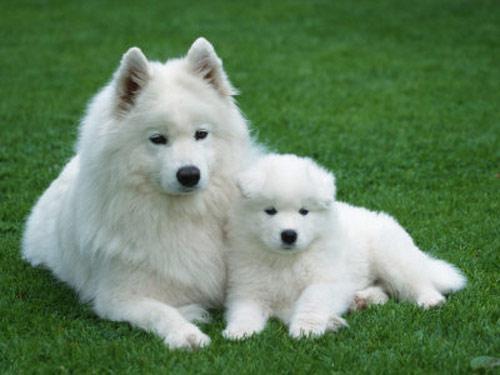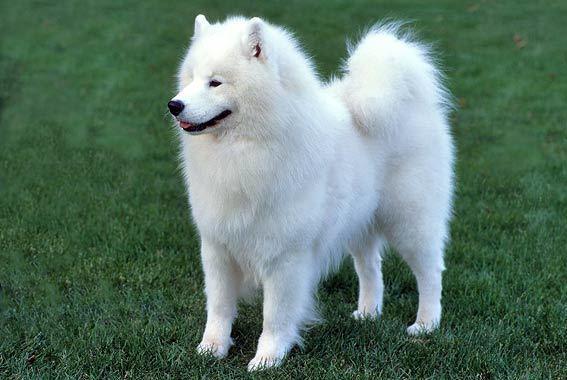The first image is the image on the left, the second image is the image on the right. Evaluate the accuracy of this statement regarding the images: "Combined, the images contain exactly four animals.". Is it true? Answer yes or no. No. The first image is the image on the left, the second image is the image on the right. Assess this claim about the two images: "There are two dogs in the image on the left.". Correct or not? Answer yes or no. Yes. 